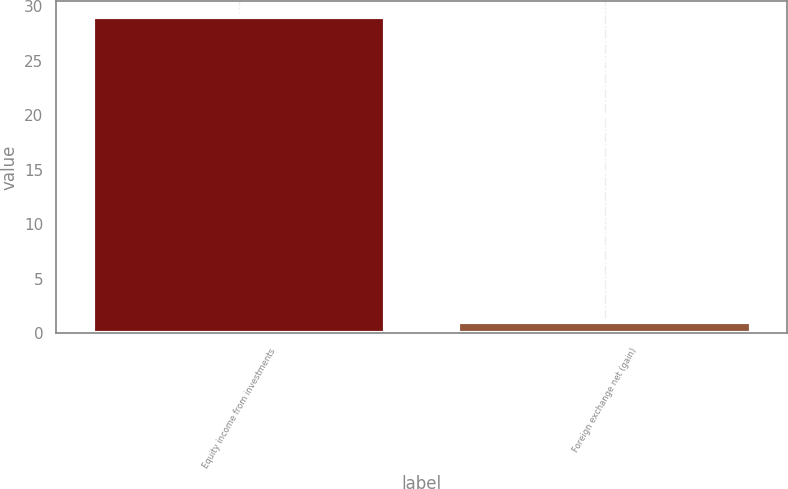Convert chart. <chart><loc_0><loc_0><loc_500><loc_500><bar_chart><fcel>Equity income from investments<fcel>Foreign exchange net (gain)<nl><fcel>29<fcel>1<nl></chart> 